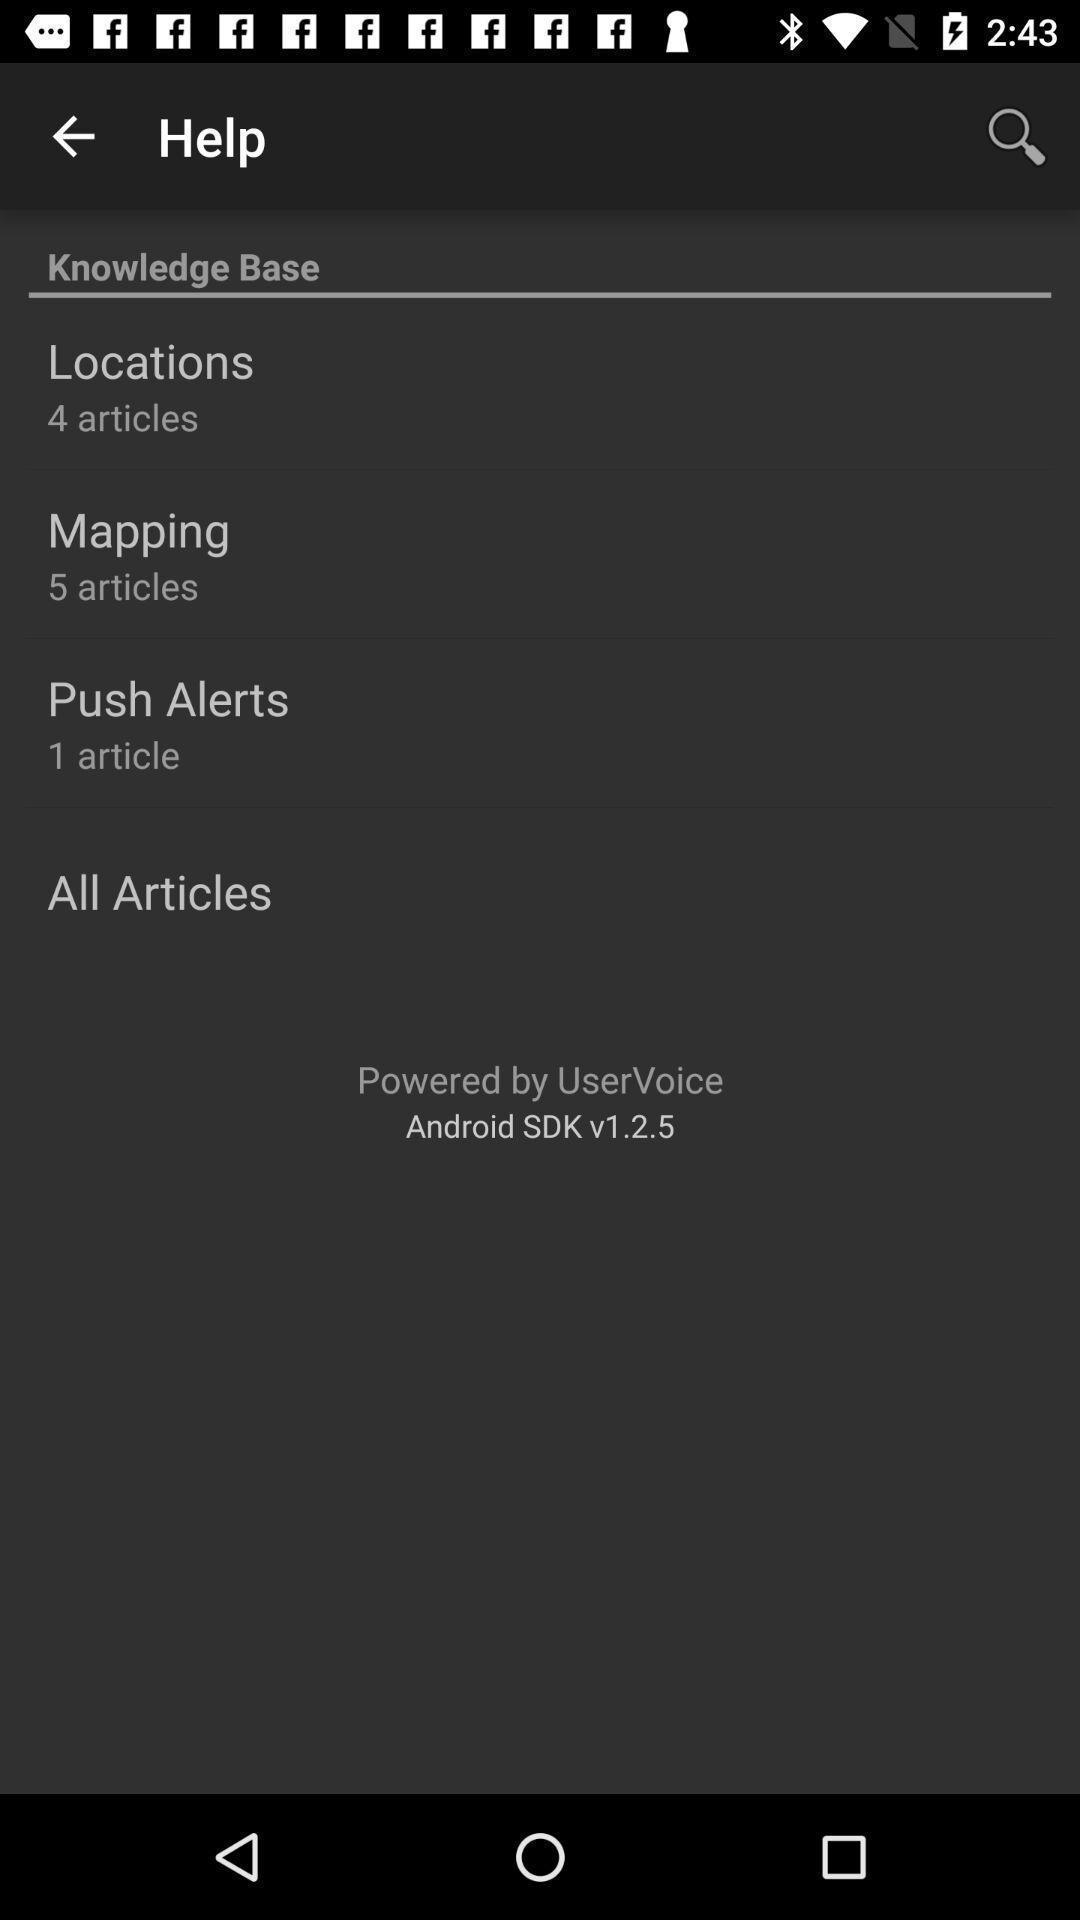Explain what's happening in this screen capture. Screen showing help page. 